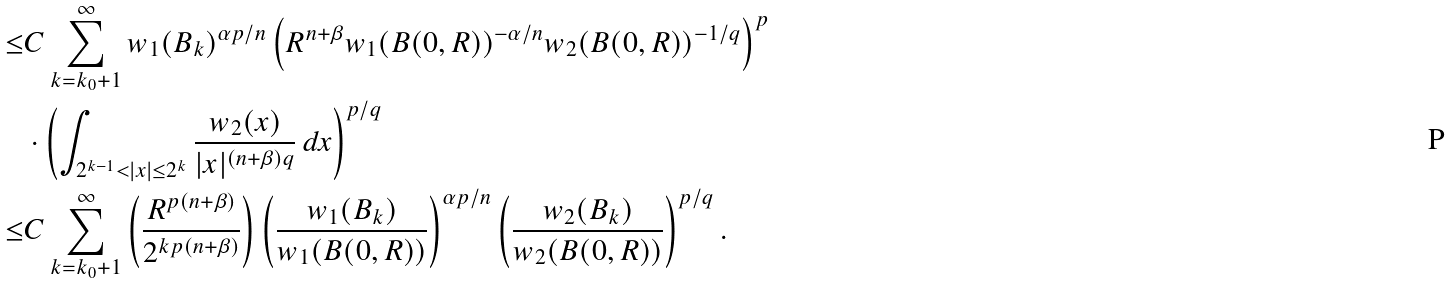Convert formula to latex. <formula><loc_0><loc_0><loc_500><loc_500>\leq & C \sum _ { k = k _ { 0 } + 1 } ^ { \infty } w _ { 1 } ( B _ { k } ) ^ { { \alpha p } / n } \left ( R ^ { n + \beta } w _ { 1 } ( B ( 0 , R ) ) ^ { - \alpha / n } w _ { 2 } ( B ( 0 , R ) ) ^ { - 1 / q } \right ) ^ { p } \\ & \cdot \left ( \int _ { 2 ^ { k - 1 } < | x | \leq 2 ^ { k } } \frac { w _ { 2 } ( x ) } { | x | ^ { ( n + \beta ) q } } \, d x \right ) ^ { p / q } \\ \leq & C \sum _ { k = k _ { 0 } + 1 } ^ { \infty } \left ( \frac { R ^ { p ( n + \beta ) } } { 2 ^ { k p ( n + \beta ) } } \right ) \left ( \frac { w _ { 1 } ( B _ { k } ) } { w _ { 1 } ( B ( 0 , R ) ) } \right ) ^ { { \alpha p } / n } \left ( \frac { w _ { 2 } ( B _ { k } ) } { w _ { 2 } ( B ( 0 , R ) ) } \right ) ^ { p / q } .</formula> 